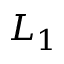<formula> <loc_0><loc_0><loc_500><loc_500>L _ { 1 }</formula> 